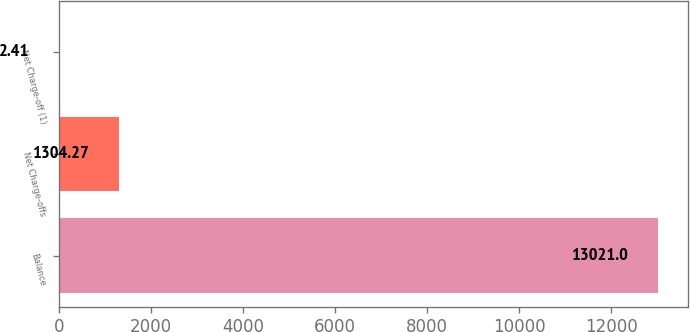Convert chart to OTSL. <chart><loc_0><loc_0><loc_500><loc_500><bar_chart><fcel>Balance<fcel>Net Charge-offs<fcel>Net Charge-off (1)<nl><fcel>13021<fcel>1304.27<fcel>2.41<nl></chart> 